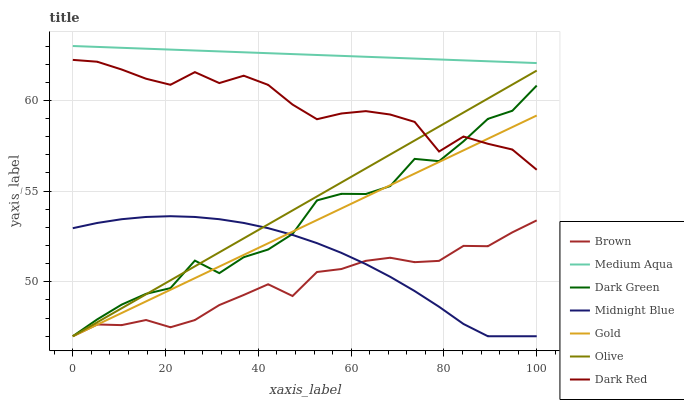Does Brown have the minimum area under the curve?
Answer yes or no. Yes. Does Medium Aqua have the maximum area under the curve?
Answer yes or no. Yes. Does Midnight Blue have the minimum area under the curve?
Answer yes or no. No. Does Midnight Blue have the maximum area under the curve?
Answer yes or no. No. Is Olive the smoothest?
Answer yes or no. Yes. Is Dark Green the roughest?
Answer yes or no. Yes. Is Midnight Blue the smoothest?
Answer yes or no. No. Is Midnight Blue the roughest?
Answer yes or no. No. Does Brown have the lowest value?
Answer yes or no. Yes. Does Dark Red have the lowest value?
Answer yes or no. No. Does Medium Aqua have the highest value?
Answer yes or no. Yes. Does Midnight Blue have the highest value?
Answer yes or no. No. Is Gold less than Medium Aqua?
Answer yes or no. Yes. Is Medium Aqua greater than Brown?
Answer yes or no. Yes. Does Dark Green intersect Gold?
Answer yes or no. Yes. Is Dark Green less than Gold?
Answer yes or no. No. Is Dark Green greater than Gold?
Answer yes or no. No. Does Gold intersect Medium Aqua?
Answer yes or no. No. 